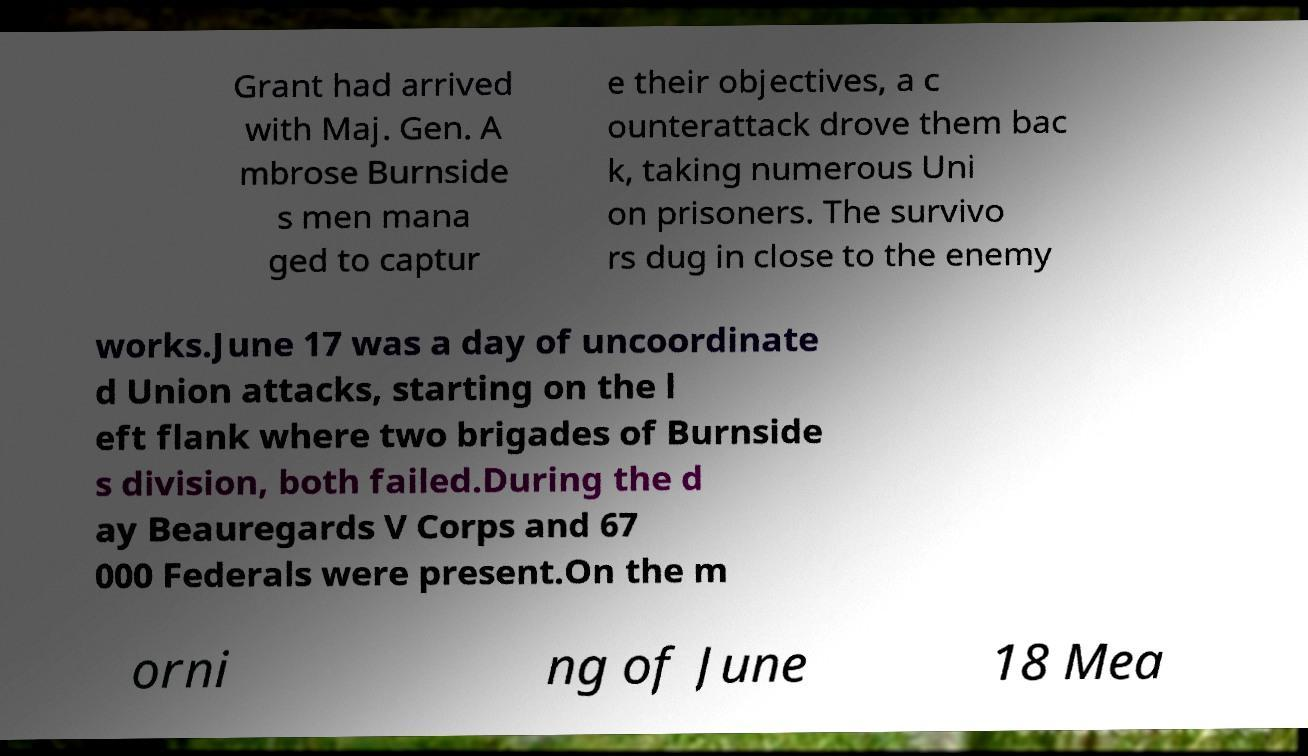I need the written content from this picture converted into text. Can you do that? Grant had arrived with Maj. Gen. A mbrose Burnside s men mana ged to captur e their objectives, a c ounterattack drove them bac k, taking numerous Uni on prisoners. The survivo rs dug in close to the enemy works.June 17 was a day of uncoordinate d Union attacks, starting on the l eft flank where two brigades of Burnside s division, both failed.During the d ay Beauregards V Corps and 67 000 Federals were present.On the m orni ng of June 18 Mea 